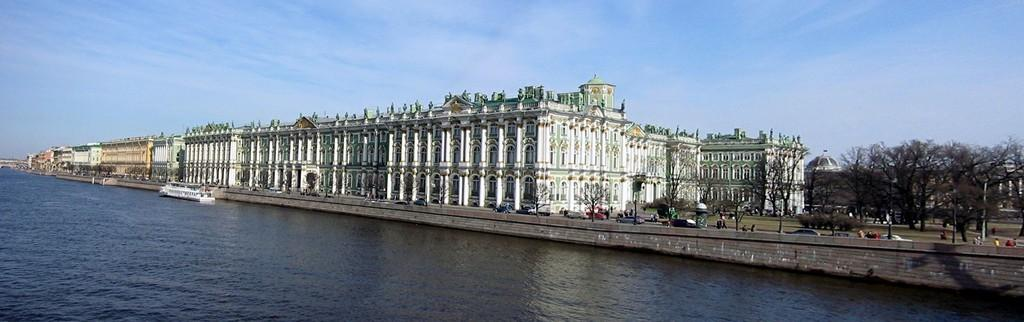What is one of the main elements in the image? There is water in the image. What type of structures can be seen in the image? There are buildings in the image. What natural elements are present in the image? There are trees in the image. What man-made objects can be seen in the image? There are vehicles in the image. What can be seen in the sky in the image? There are clouds in the image. What part of the sky is visible in the image? The sky is visible in the image. Who or what is present in the image? There are people in the image. What type of bone can be seen in the image? There is no bone present in the image. What is the opinion of the clouds in the image? The clouds in the image do not have an opinion, as they are inanimate objects. 